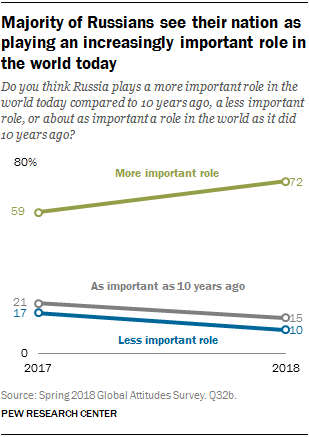Highlight a few significant elements in this photo. The highest value of gray in a graph is 21. The sum of the highest value of the gray and blue graphs is greater than the smallest value of the green graph. 